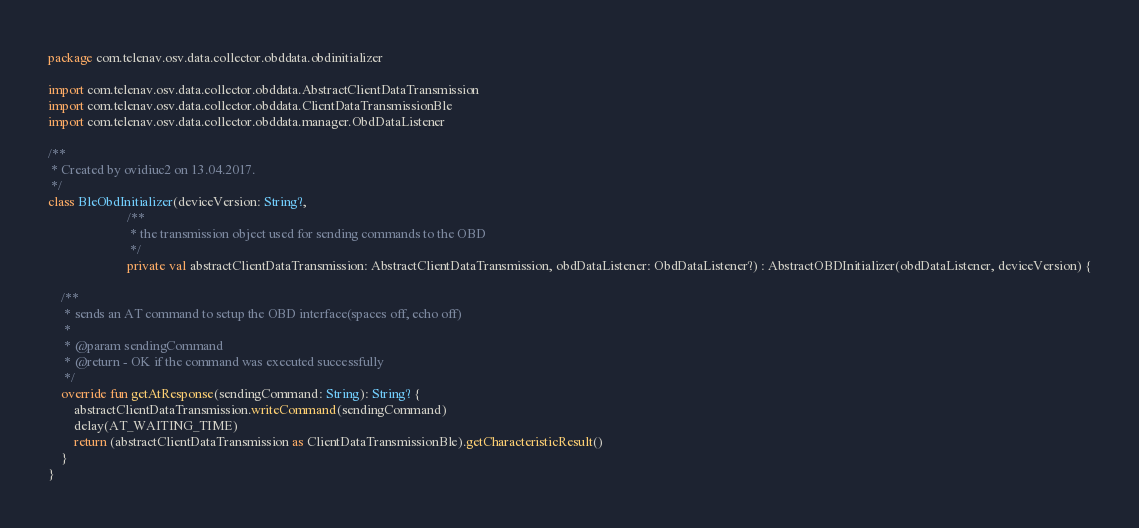<code> <loc_0><loc_0><loc_500><loc_500><_Kotlin_>package com.telenav.osv.data.collector.obddata.obdinitializer

import com.telenav.osv.data.collector.obddata.AbstractClientDataTransmission
import com.telenav.osv.data.collector.obddata.ClientDataTransmissionBle
import com.telenav.osv.data.collector.obddata.manager.ObdDataListener

/**
 * Created by ovidiuc2 on 13.04.2017.
 */
class BleObdInitializer(deviceVersion: String?,
                        /**
                         * the transmission object used for sending commands to the OBD
                         */
                        private val abstractClientDataTransmission: AbstractClientDataTransmission, obdDataListener: ObdDataListener?) : AbstractOBDInitializer(obdDataListener, deviceVersion) {

    /**
     * sends an AT command to setup the OBD interface(spaces off, echo off)
     *
     * @param sendingCommand
     * @return - OK if the command was executed successfully
     */
    override fun getAtResponse(sendingCommand: String): String? {
        abstractClientDataTransmission.writeCommand(sendingCommand)
        delay(AT_WAITING_TIME)
        return (abstractClientDataTransmission as ClientDataTransmissionBle).getCharacteristicResult()
    }
}</code> 